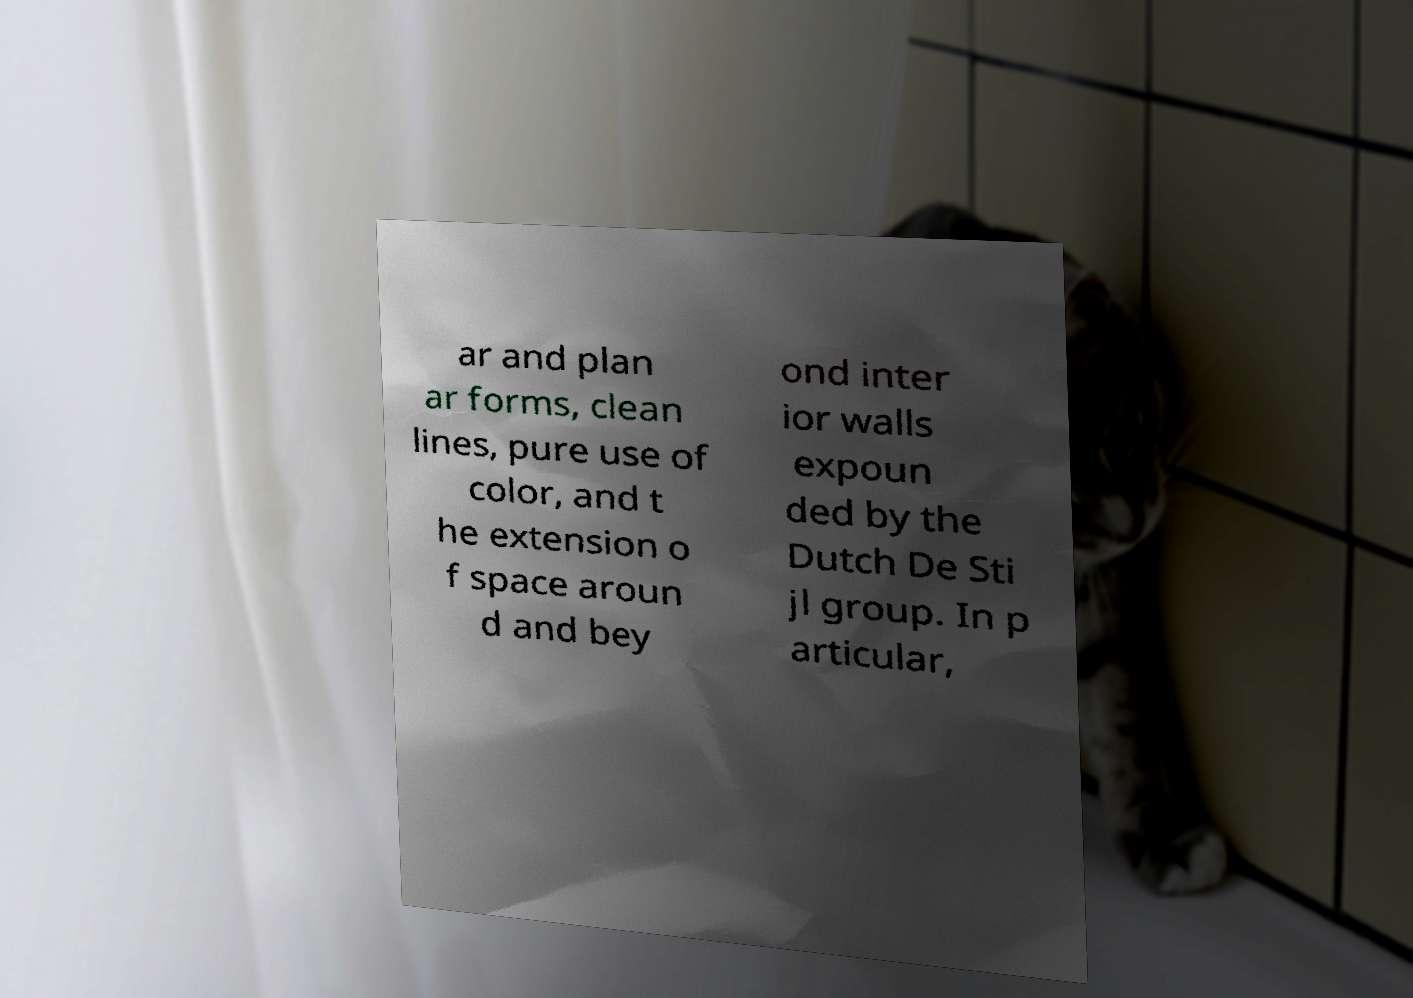Could you assist in decoding the text presented in this image and type it out clearly? ar and plan ar forms, clean lines, pure use of color, and t he extension o f space aroun d and bey ond inter ior walls expoun ded by the Dutch De Sti jl group. In p articular, 